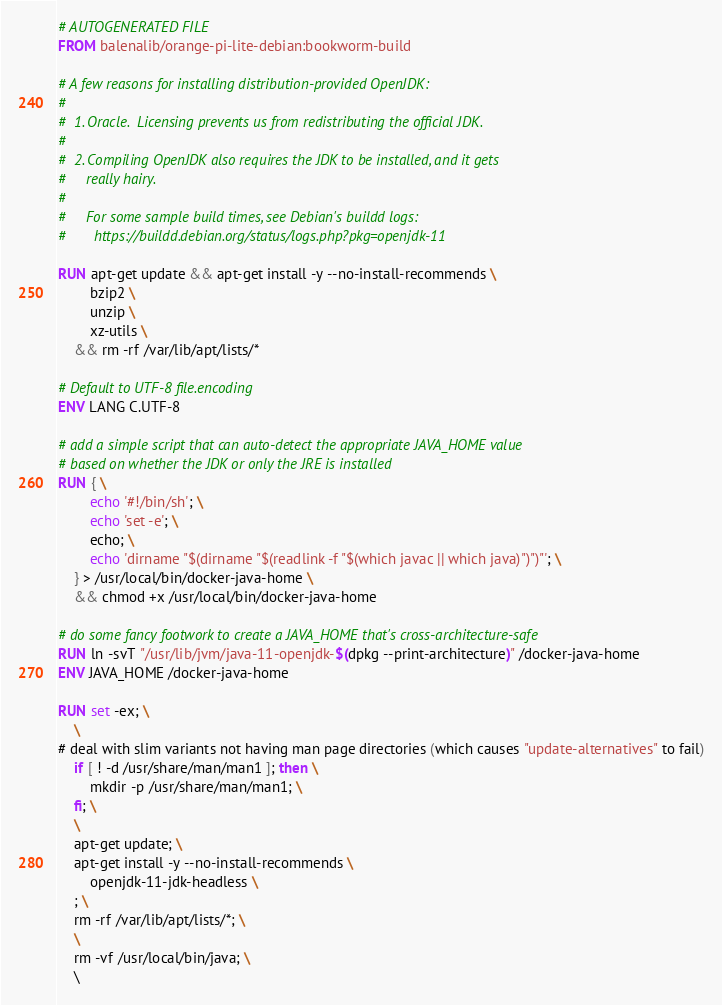Convert code to text. <code><loc_0><loc_0><loc_500><loc_500><_Dockerfile_># AUTOGENERATED FILE
FROM balenalib/orange-pi-lite-debian:bookworm-build

# A few reasons for installing distribution-provided OpenJDK:
#
#  1. Oracle.  Licensing prevents us from redistributing the official JDK.
#
#  2. Compiling OpenJDK also requires the JDK to be installed, and it gets
#     really hairy.
#
#     For some sample build times, see Debian's buildd logs:
#       https://buildd.debian.org/status/logs.php?pkg=openjdk-11

RUN apt-get update && apt-get install -y --no-install-recommends \
		bzip2 \
		unzip \
		xz-utils \
	&& rm -rf /var/lib/apt/lists/*

# Default to UTF-8 file.encoding
ENV LANG C.UTF-8

# add a simple script that can auto-detect the appropriate JAVA_HOME value
# based on whether the JDK or only the JRE is installed
RUN { \
		echo '#!/bin/sh'; \
		echo 'set -e'; \
		echo; \
		echo 'dirname "$(dirname "$(readlink -f "$(which javac || which java)")")"'; \
	} > /usr/local/bin/docker-java-home \
	&& chmod +x /usr/local/bin/docker-java-home

# do some fancy footwork to create a JAVA_HOME that's cross-architecture-safe
RUN ln -svT "/usr/lib/jvm/java-11-openjdk-$(dpkg --print-architecture)" /docker-java-home
ENV JAVA_HOME /docker-java-home

RUN set -ex; \
	\
# deal with slim variants not having man page directories (which causes "update-alternatives" to fail)
	if [ ! -d /usr/share/man/man1 ]; then \
		mkdir -p /usr/share/man/man1; \
	fi; \
	\
	apt-get update; \
	apt-get install -y --no-install-recommends \
		openjdk-11-jdk-headless \
	; \
	rm -rf /var/lib/apt/lists/*; \
	\
	rm -vf /usr/local/bin/java; \
	\</code> 